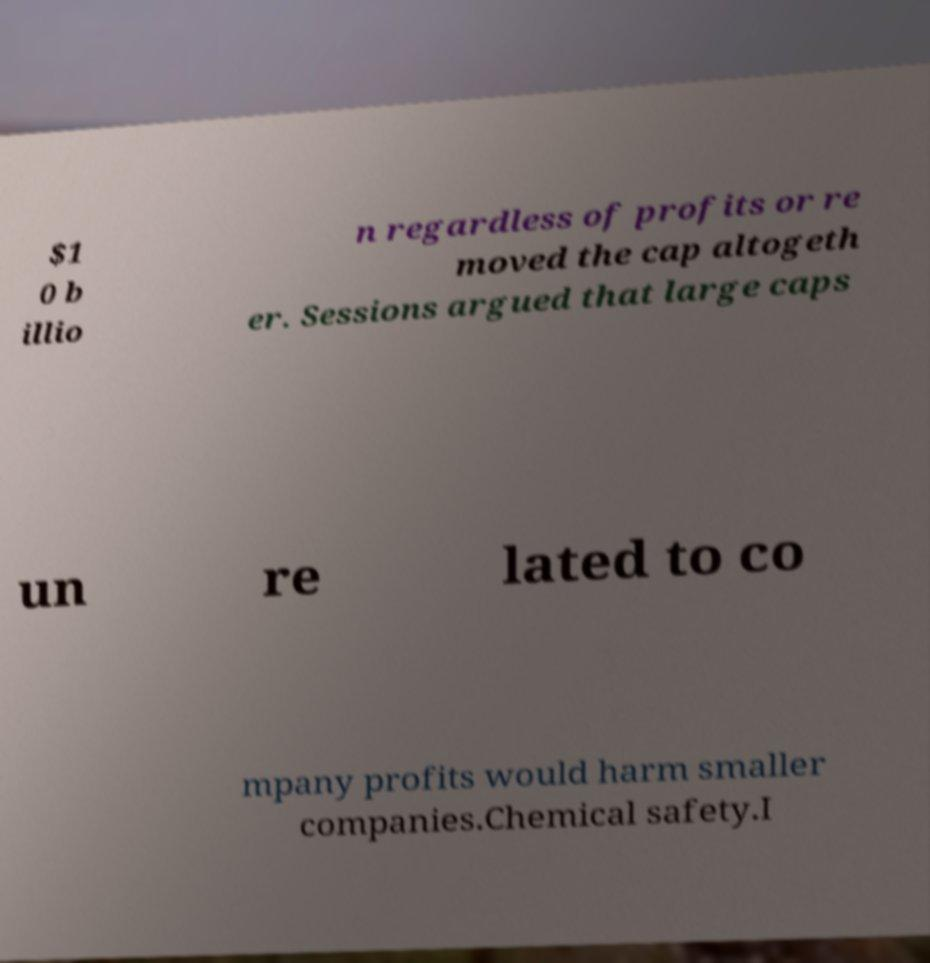Could you assist in decoding the text presented in this image and type it out clearly? $1 0 b illio n regardless of profits or re moved the cap altogeth er. Sessions argued that large caps un re lated to co mpany profits would harm smaller companies.Chemical safety.I 